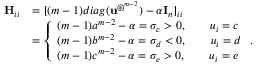<formula> <loc_0><loc_0><loc_500><loc_500>\begin{array} { r l } { \mathbf H _ { i i } } & { = [ ( m - 1 ) d i a g ( \mathbf u ^ { \circledast ^ { m - 2 } } ) - \alpha \mathbf I _ { n } ] _ { i i } } \\ & { = \left \{ \begin{array} { l l } { ( m - 1 ) a ^ { m - 2 } - \alpha = \sigma _ { c } > 0 , \quad u _ { i } = c } \\ { ( m - 1 ) b ^ { m - 2 } - \alpha = \sigma _ { d } < 0 , \quad u _ { i } = d } \\ { ( m - 1 ) c ^ { m - 2 } - \alpha = \sigma _ { e } > 0 , \quad u _ { i } = e } \end{array} . } \end{array}</formula> 